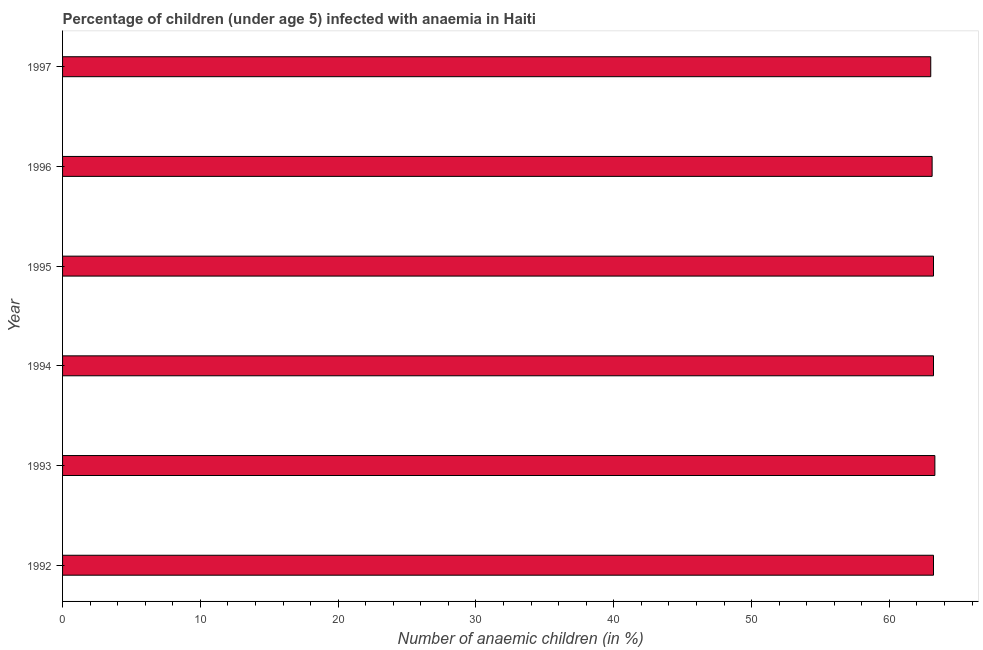Does the graph contain grids?
Offer a very short reply. No. What is the title of the graph?
Make the answer very short. Percentage of children (under age 5) infected with anaemia in Haiti. What is the label or title of the X-axis?
Your answer should be compact. Number of anaemic children (in %). What is the number of anaemic children in 1996?
Provide a short and direct response. 63.1. Across all years, what is the maximum number of anaemic children?
Your response must be concise. 63.3. In which year was the number of anaemic children maximum?
Give a very brief answer. 1993. What is the sum of the number of anaemic children?
Provide a short and direct response. 379. What is the average number of anaemic children per year?
Provide a short and direct response. 63.17. What is the median number of anaemic children?
Offer a very short reply. 63.2. In how many years, is the number of anaemic children greater than 60 %?
Make the answer very short. 6. Do a majority of the years between 1995 and 1996 (inclusive) have number of anaemic children greater than 14 %?
Give a very brief answer. Yes. What is the ratio of the number of anaemic children in 1994 to that in 1996?
Your response must be concise. 1. What is the difference between the highest and the second highest number of anaemic children?
Your response must be concise. 0.1. Are all the bars in the graph horizontal?
Ensure brevity in your answer.  Yes. How many years are there in the graph?
Keep it short and to the point. 6. What is the difference between two consecutive major ticks on the X-axis?
Give a very brief answer. 10. Are the values on the major ticks of X-axis written in scientific E-notation?
Offer a very short reply. No. What is the Number of anaemic children (in %) in 1992?
Keep it short and to the point. 63.2. What is the Number of anaemic children (in %) in 1993?
Ensure brevity in your answer.  63.3. What is the Number of anaemic children (in %) of 1994?
Your answer should be very brief. 63.2. What is the Number of anaemic children (in %) of 1995?
Provide a short and direct response. 63.2. What is the Number of anaemic children (in %) of 1996?
Offer a terse response. 63.1. What is the Number of anaemic children (in %) in 1997?
Provide a succinct answer. 63. What is the difference between the Number of anaemic children (in %) in 1992 and 1993?
Your response must be concise. -0.1. What is the difference between the Number of anaemic children (in %) in 1992 and 1994?
Ensure brevity in your answer.  0. What is the difference between the Number of anaemic children (in %) in 1992 and 1997?
Make the answer very short. 0.2. What is the difference between the Number of anaemic children (in %) in 1993 and 1994?
Your answer should be compact. 0.1. What is the difference between the Number of anaemic children (in %) in 1993 and 1995?
Offer a terse response. 0.1. What is the difference between the Number of anaemic children (in %) in 1993 and 1996?
Ensure brevity in your answer.  0.2. What is the difference between the Number of anaemic children (in %) in 1994 and 1996?
Your answer should be very brief. 0.1. What is the difference between the Number of anaemic children (in %) in 1994 and 1997?
Make the answer very short. 0.2. What is the difference between the Number of anaemic children (in %) in 1995 and 1996?
Give a very brief answer. 0.1. What is the difference between the Number of anaemic children (in %) in 1995 and 1997?
Offer a very short reply. 0.2. What is the ratio of the Number of anaemic children (in %) in 1992 to that in 1993?
Offer a terse response. 1. What is the ratio of the Number of anaemic children (in %) in 1992 to that in 1994?
Your answer should be compact. 1. What is the ratio of the Number of anaemic children (in %) in 1992 to that in 1995?
Provide a succinct answer. 1. What is the ratio of the Number of anaemic children (in %) in 1992 to that in 1997?
Offer a very short reply. 1. What is the ratio of the Number of anaemic children (in %) in 1993 to that in 1994?
Give a very brief answer. 1. What is the ratio of the Number of anaemic children (in %) in 1993 to that in 1996?
Your answer should be compact. 1. What is the ratio of the Number of anaemic children (in %) in 1993 to that in 1997?
Your answer should be very brief. 1. What is the ratio of the Number of anaemic children (in %) in 1994 to that in 1995?
Make the answer very short. 1. What is the ratio of the Number of anaemic children (in %) in 1994 to that in 1996?
Provide a short and direct response. 1. 